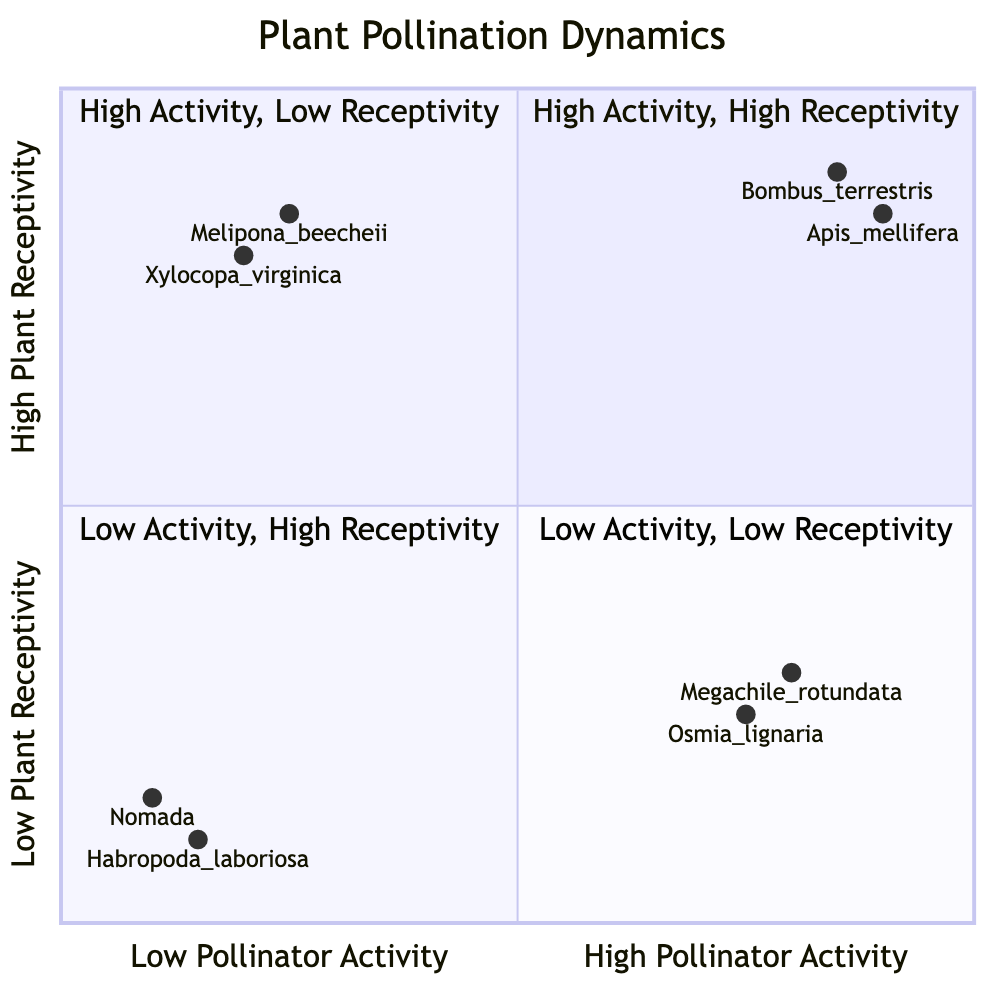What pollinator is associated with high activity and high plant receptivity? The question focuses on identifying a specific pollinator located in the first quadrant (Q1), which is characterized by both high pollinator activity and high plant receptivity. Referring to the data for Q1, we find that Apis mellifera (female worker bee) and Bombus terrestris (female bumblebee) are examples. Thus, either can serve as an answer.
Answer: Apis mellifera (female worker bee) What type of plant is associated with low pollinator activity but high plant receptivity? This question asks for a plant found in quadrant three (Q3). By examining Q3's examples, we see that both Prunus avium (Cherry, early bloom) and Cucurbita pepo (Zucchini, peak bloom) qualify since they exist in an area with low pollinators but high receptivity. Either plant can be named as the answer.
Answer: Prunus avium (Cherry, early bloom) How many examples are found in quadrant two? This question requires counting the number of examples listed in quadrant two (Q2). There are two specific examples of pollinators and plants: Megachile rotundata (female leafcutter bee) and Osmia lignaria (female mason bee), giving a total count of examples in this quadrant.
Answer: 2 Which quadrant is characterized by low pollinator activity and low plant receptivity? This question asks for the identification of a quadrant based on its characteristics. By looking at the descriptions, quadrant four (Q4) describes zones with low pollinator activity and low plant receptivity. Thus, the answer refers to this specific quadrant.
Answer: Q4 Which female bee is associated with a flowering plant that is post-bloom and has low receptivity? The question aims to find a specific example within quadrant four (Q4), which is characterized by low pollinator activity and low plant receptivity. In Q4, one example is Habropoda laboriosa (female southeastern blueberry bee) with Lonicera japonica (Japanese Honeysuckle, post-bloom). This pair represents the required relationship of low receptivity.
Answer: Habropoda laboriosa (female southeastern blueberry bee) Which flowering plant is paired with Megachile rotundata? This inquiry pertains to identifying the specific flowering plant associated with the female leafcutter bee, Megachile rotundata, found in quadrant two (Q2). The corresponding plant, according to the data, is Taraxacum officinale (Dandelion, post-bloom).
Answer: Taraxacum officinale (Dandelion, post-bloom) What is the priority designation for areas with both low pollinator activity and high plant receptivity? The question addresses the identification of the appropriate quadrant for the described dynamics. By analyzing quadrant three (Q3), we confirm it is designated for low pollinator activity yet high plant receptivity.
Answer: Q3 How does the pollinator activity of Xylocopa virginica compare to that of female bees in Q1? This question requires comparing the activity levels of Xylocopa virginica, a female carpenter bee listed in Q3, to the female bees in quadrant one (Q1). In Q1, both Apis mellifera and Bombus terrestris have high activity values (close to 0.9), while Xylocopa virginica has a low activity value of 0.2. This indicates that Xylocopa virginica has significantly lower activity compared to those in Q1.
Answer: Lower Do any female pollinators show activity below 0.2? This question seeks to identify whether there are any female pollinators in the dataset that exhibit an activity level below 0.2. Upon reviewing the information, the only female pollinator with such low activity is Nomada, which shows an activity of 0.1.
Answer: Yes 